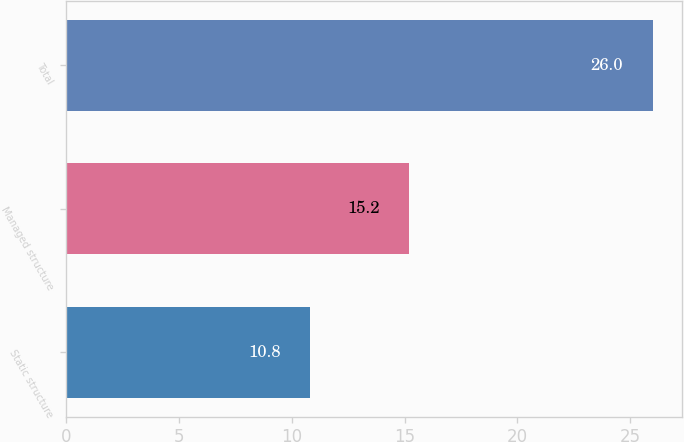Convert chart. <chart><loc_0><loc_0><loc_500><loc_500><bar_chart><fcel>Static structure<fcel>Managed structure<fcel>Total<nl><fcel>10.8<fcel>15.2<fcel>26<nl></chart> 